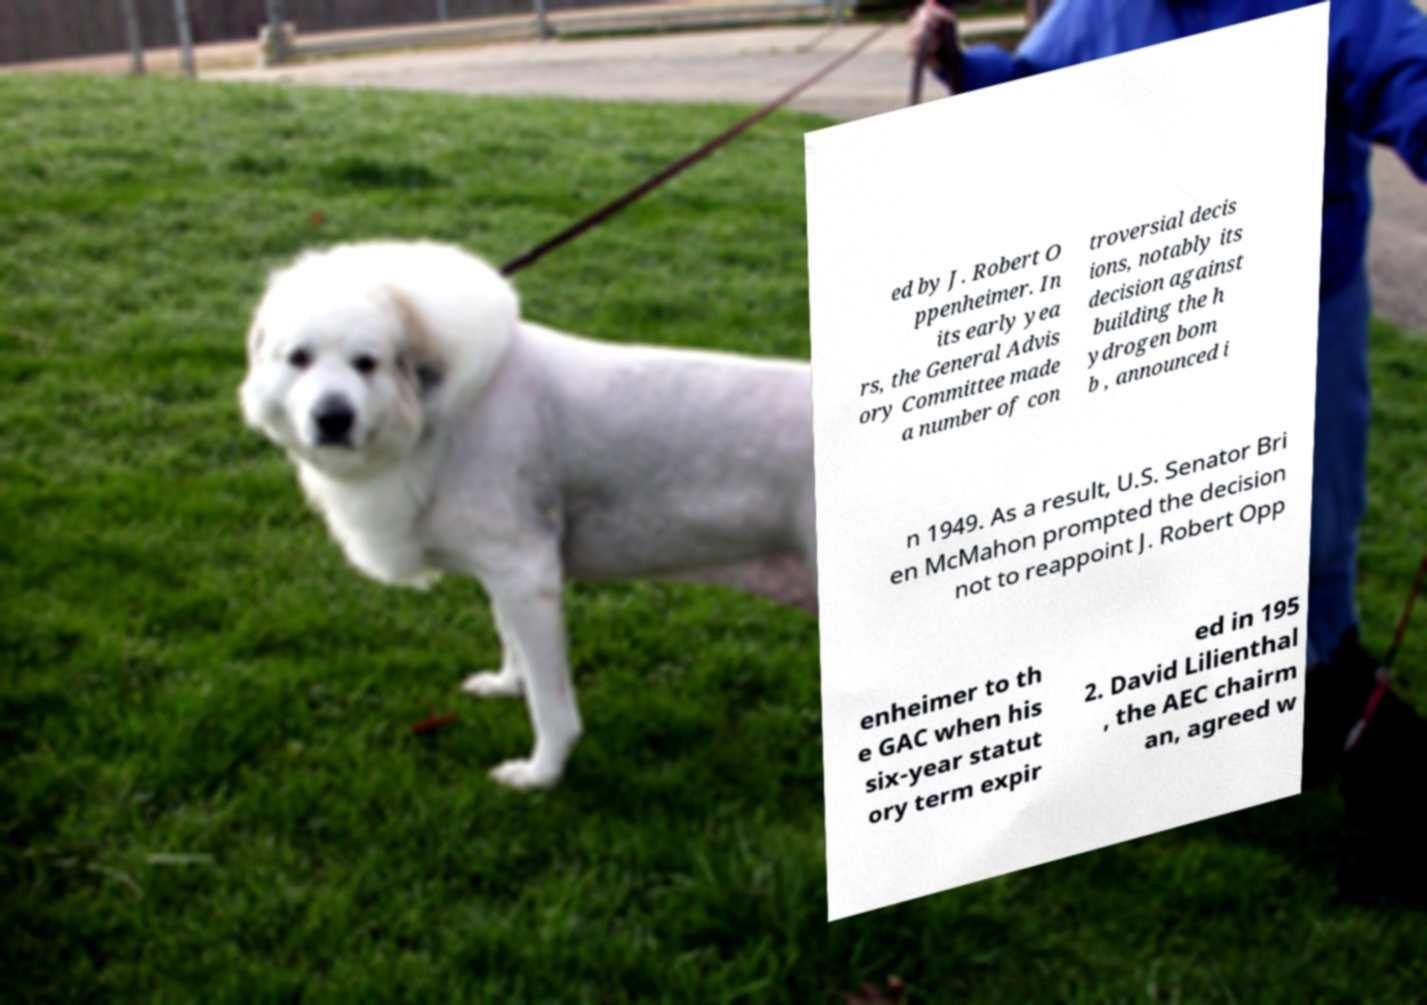Could you extract and type out the text from this image? ed by J. Robert O ppenheimer. In its early yea rs, the General Advis ory Committee made a number of con troversial decis ions, notably its decision against building the h ydrogen bom b , announced i n 1949. As a result, U.S. Senator Bri en McMahon prompted the decision not to reappoint J. Robert Opp enheimer to th e GAC when his six-year statut ory term expir ed in 195 2. David Lilienthal , the AEC chairm an, agreed w 